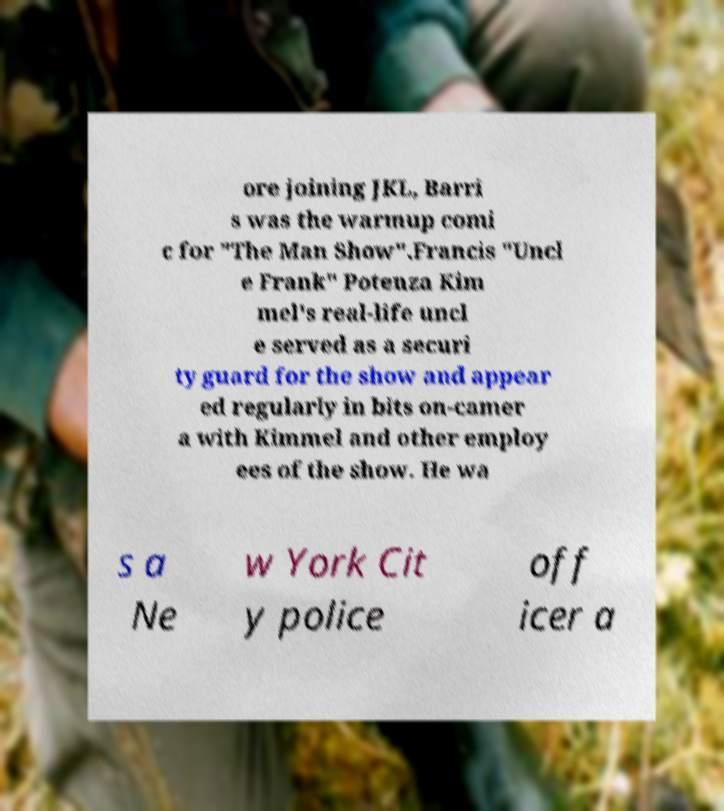For documentation purposes, I need the text within this image transcribed. Could you provide that? ore joining JKL, Barri s was the warmup comi c for "The Man Show".Francis "Uncl e Frank" Potenza Kim mel's real-life uncl e served as a securi ty guard for the show and appear ed regularly in bits on-camer a with Kimmel and other employ ees of the show. He wa s a Ne w York Cit y police off icer a 